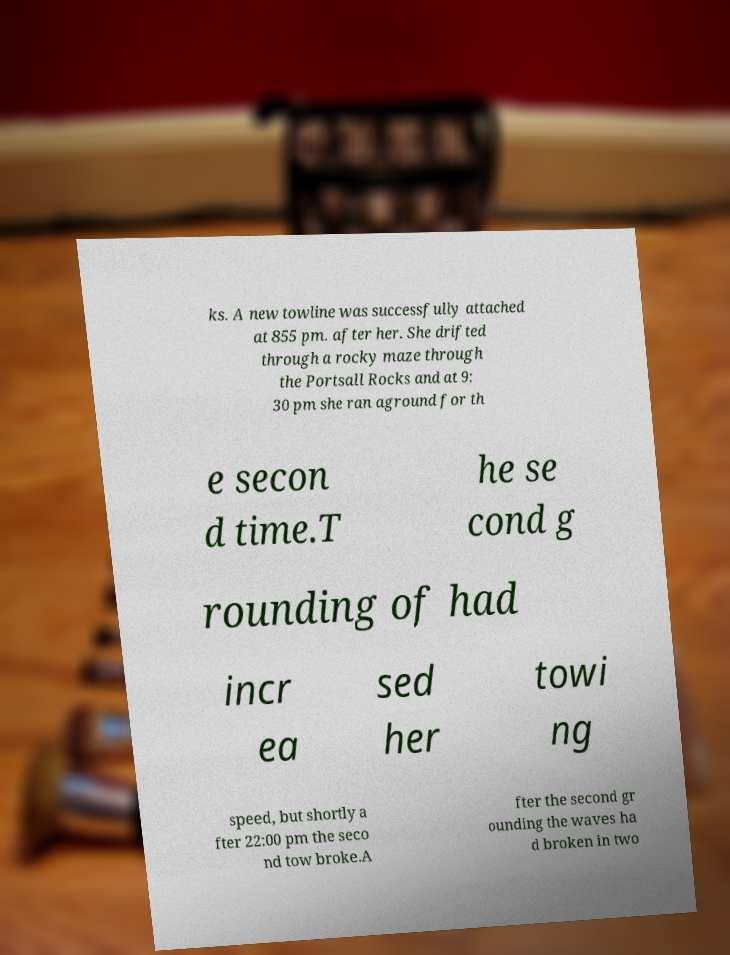Can you accurately transcribe the text from the provided image for me? ks. A new towline was successfully attached at 855 pm. after her. She drifted through a rocky maze through the Portsall Rocks and at 9: 30 pm she ran aground for th e secon d time.T he se cond g rounding of had incr ea sed her towi ng speed, but shortly a fter 22:00 pm the seco nd tow broke.A fter the second gr ounding the waves ha d broken in two 